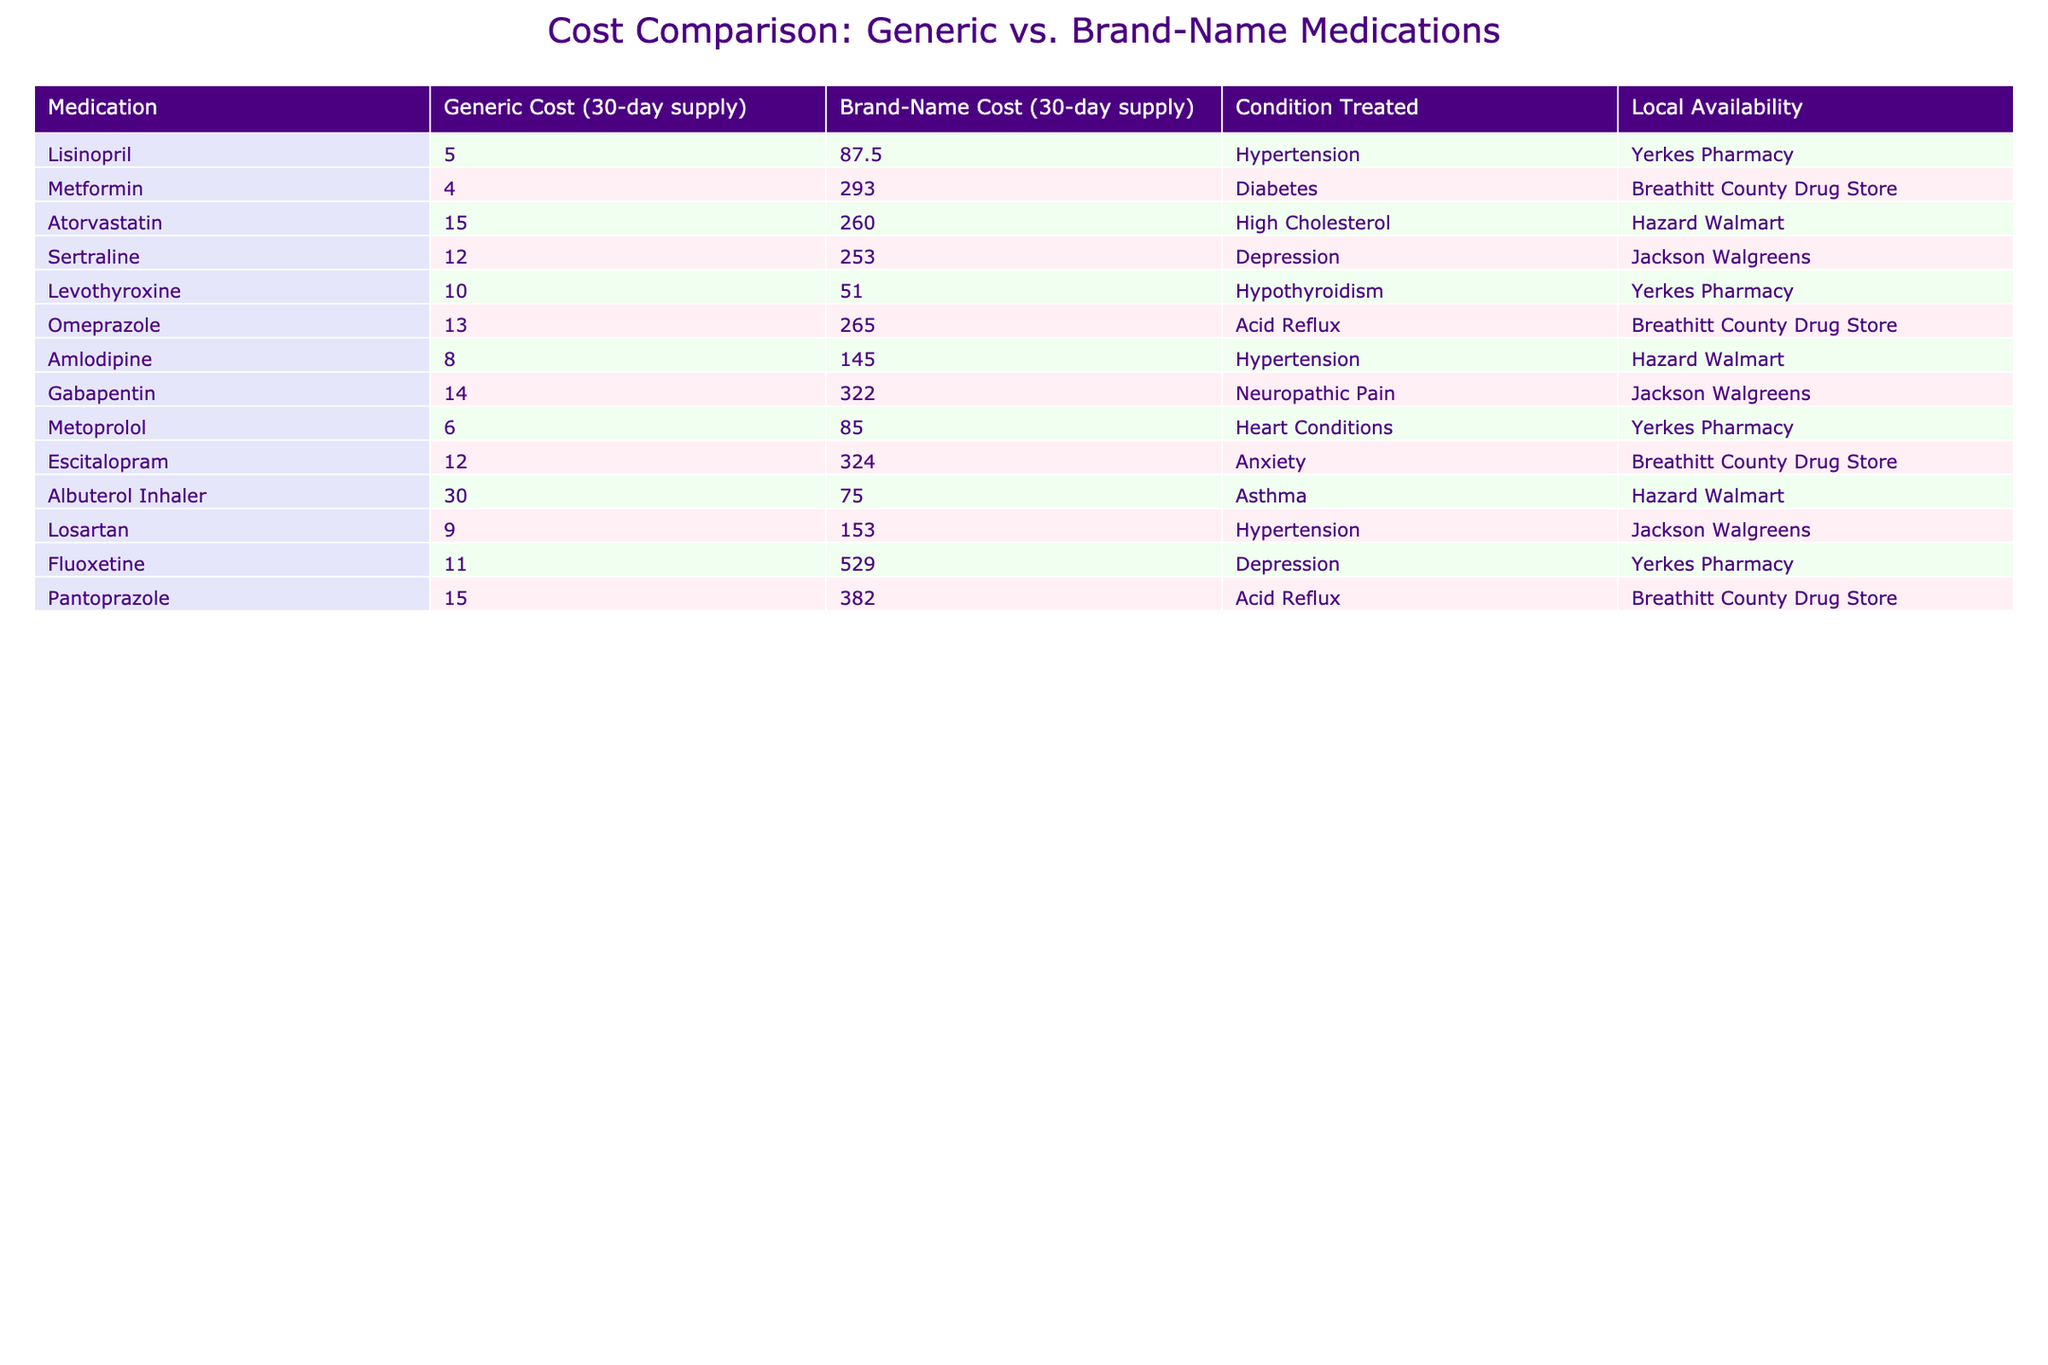What is the cost of Lisinopril as a brand-name medication? The table lists the brand-name cost of Lisinopril as 87.50.
Answer: 87.50 What is the local availability of Metformin? According to the table, Metformin is available at the Breathitt County Drug Store.
Answer: Breathitt County Drug Store What is the difference in cost between the generic and brand-name versions of Atorvastatin? The generic cost of Atorvastatin is 15.00, and the brand-name cost is 260.00. The difference is 260.00 - 15.00 = 245.00.
Answer: 245.00 Is the brand-name cost of Omeprazole higher than 200.00? The brand-name cost of Omeprazole is 265.00, which is indeed higher than 200.00.
Answer: Yes What is the average cost of the generic medications listed? To find the average cost of the generic medications, we total their costs: 5.00 + 4.00 + 15.00 + 12.00 + 10.00 + 13.00 + 8.00 + 14.00 + 6.00 + 12.00 + 30.00 + 9.00 + 11.00 =  8.92, dividing by the total of 13 medications gives an average of 8.92.
Answer: 8.92 Which medication has the highest brand-name cost in the table? Reviewing the brand-name costs, Fluoxetine at 529.00 is the highest cost compared to others.
Answer: Fluoxetine Is Levothyroxine available at the Yerkes Pharmacy? Yes, the table indicates that Levothyroxine is available at the Yerkes Pharmacy.
Answer: Yes What is the combined cost of the generic medications for hypertension? The generic medications for hypertension are Lisinopril (5.00), Amlodipine (8.00), and Losartan (9.00). Their combined cost is 5.00 + 8.00 + 9.00 = 22.00.
Answer: 22.00 How many medications in the table cost more than 250.00 as brand-name? Upon reviewing the table, the medications with brand-name costs greater than 250.00 are Metformin (293.00), Atorvastatin (260.00), Sertraline (253.00), Gabapentin (322.00), Escitalopram (324.00), Fluoxetine (529.00), and Pantoprazole (382.00), totaling 7 medications.
Answer: 7 